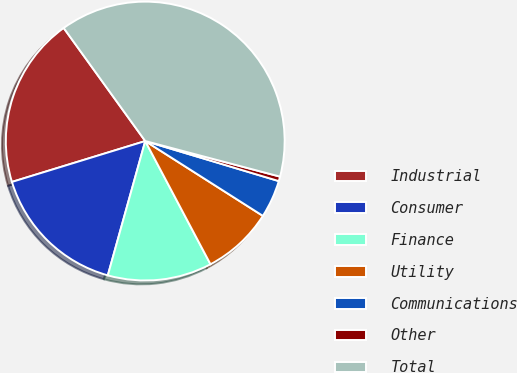<chart> <loc_0><loc_0><loc_500><loc_500><pie_chart><fcel>Industrial<fcel>Consumer<fcel>Finance<fcel>Utility<fcel>Communications<fcel>Other<fcel>Total<nl><fcel>19.79%<fcel>15.94%<fcel>12.08%<fcel>8.23%<fcel>4.38%<fcel>0.53%<fcel>39.05%<nl></chart> 